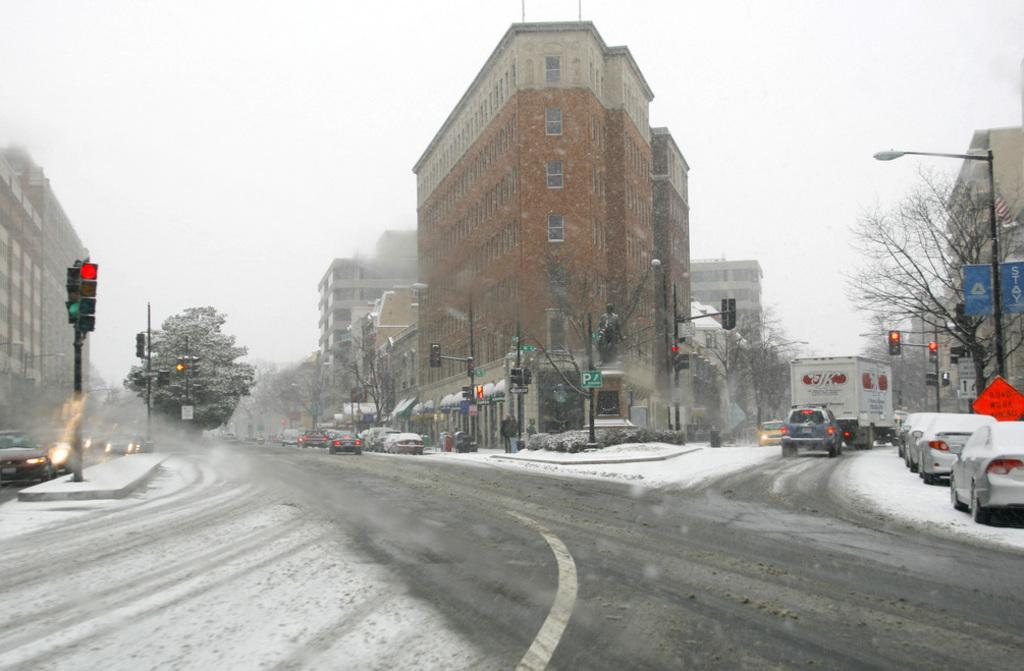What type of structures can be seen in the image? There are buildings in the image. What objects are present that are related to traffic control? There are poles, traffic lights, and sign boards in the image. What type of vegetation is visible in the image? There are trees in the image. What type of transportation can be seen in the image? There are vehicles in the image. What weather condition is depicted in the image? There is snow visible in the image. What type of insurance policy is being advertised on the sign board in the image? There is no information about insurance policies on the sign boards in the image. How many folds are visible in the quilt that is draped over the vehicle in the image? There is no quilt present in the image; it only features vehicles, buildings, poles, traffic lights, sign boards, trees, and snow. 